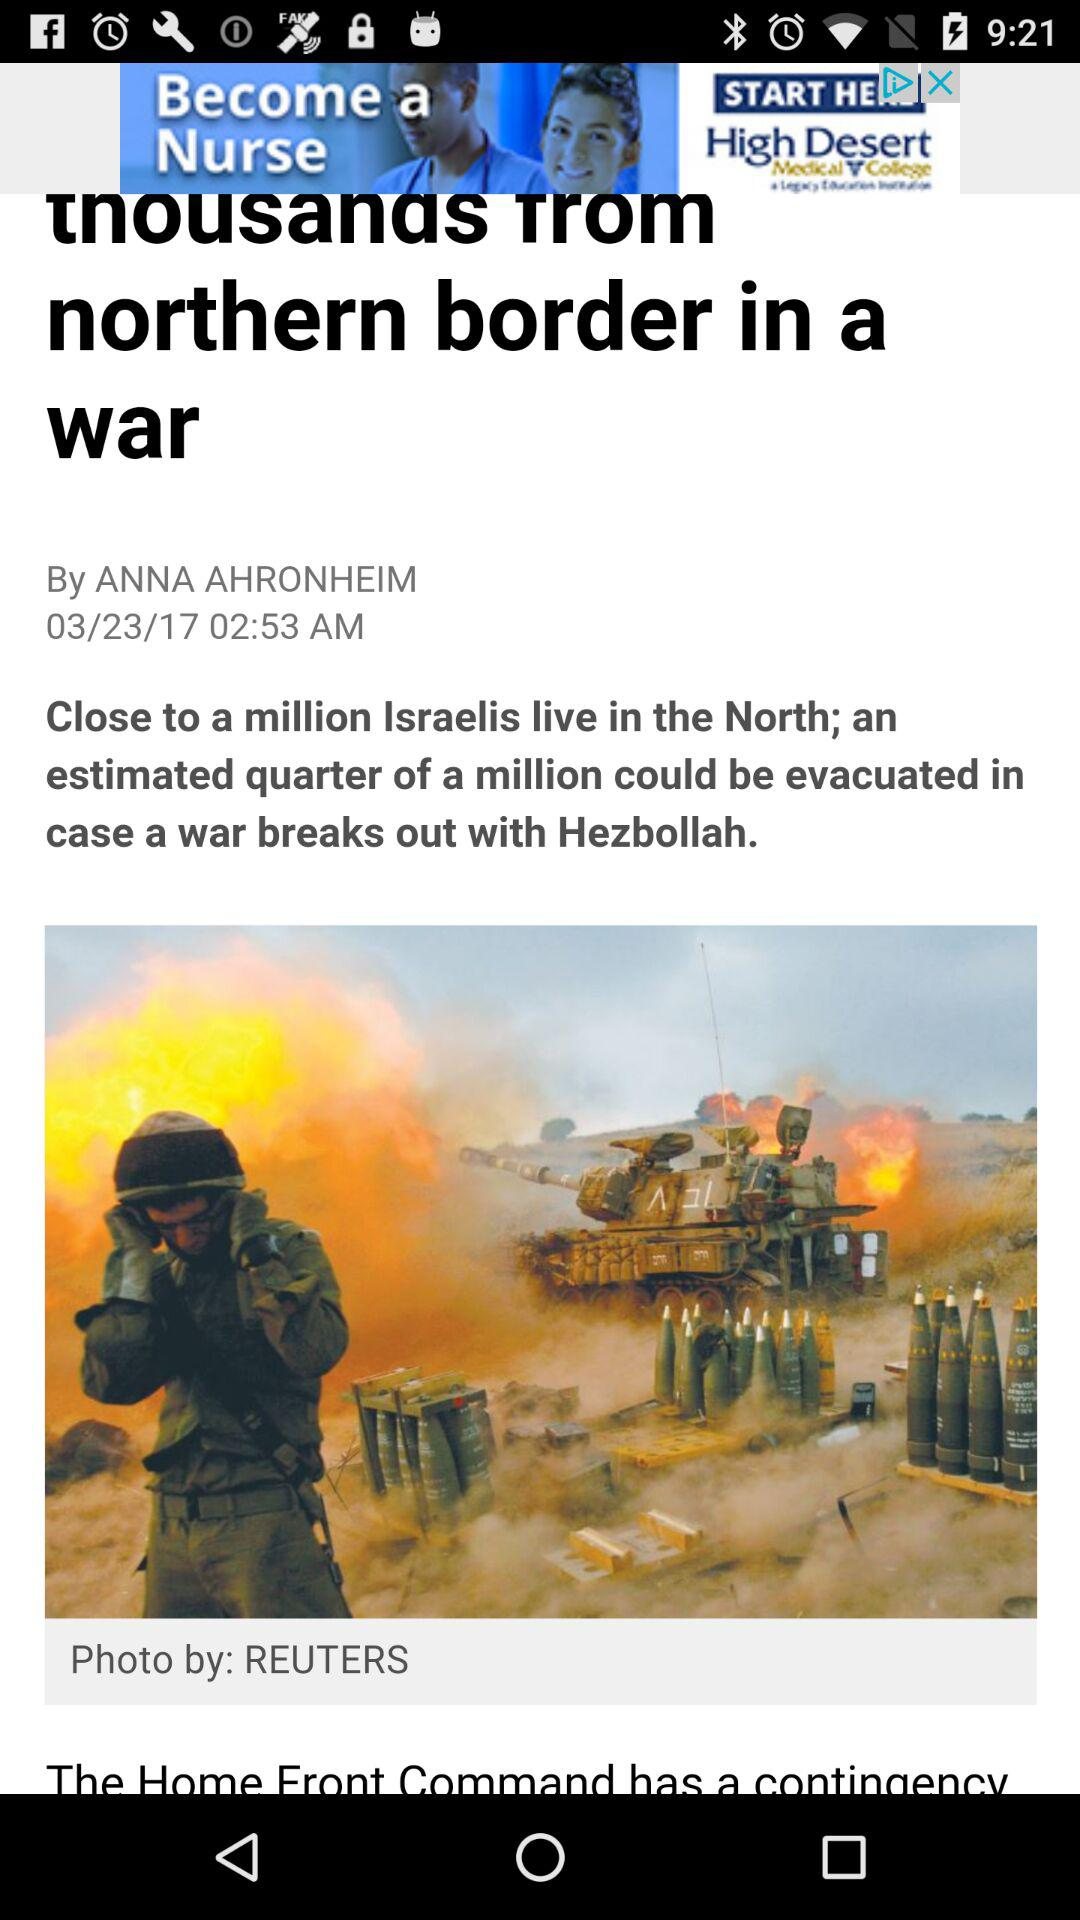At what time was the article published? The article was published at 02:53 AM. 